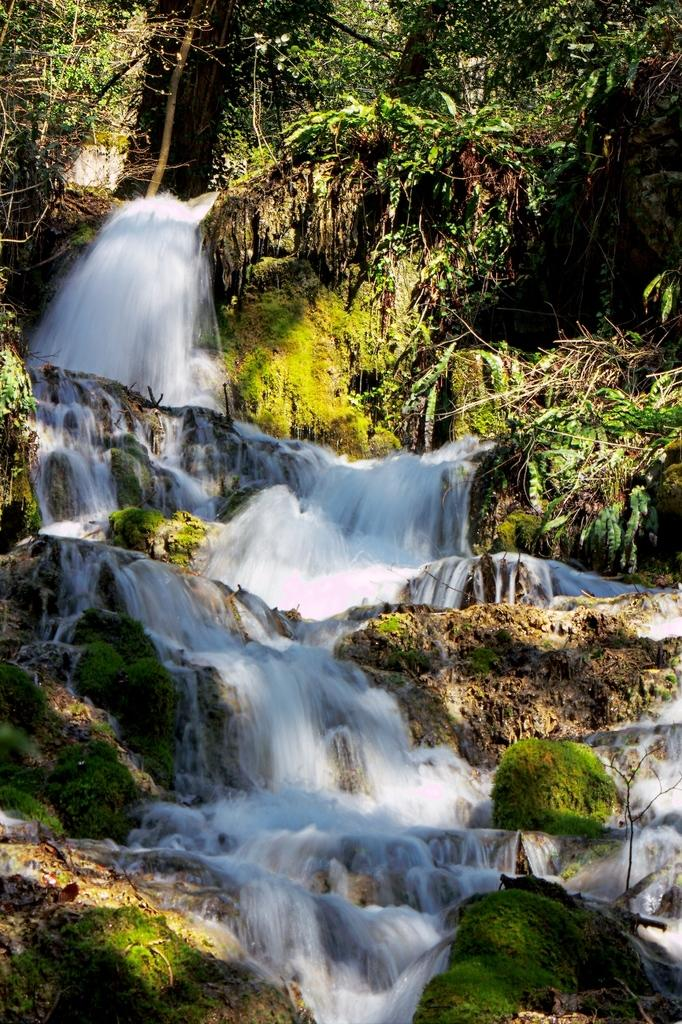What natural feature is the main subject of the image? There is a waterfall in the image. What type of vegetation can be seen in the image? There are trees and plants in the image. What type of feather can be seen floating in the waterfall in the image? There is no feather present in the image; it features a waterfall, trees, and plants. 